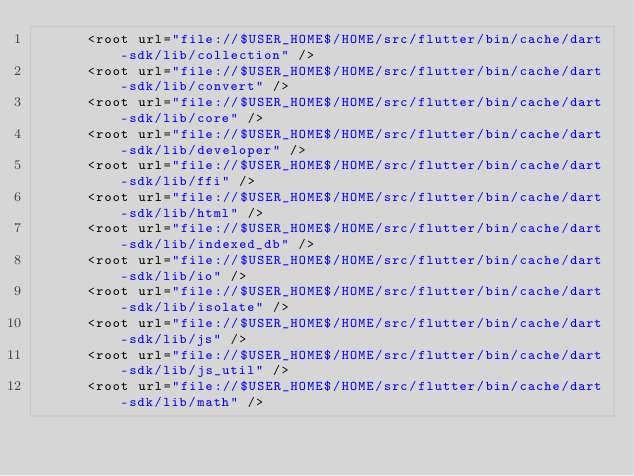Convert code to text. <code><loc_0><loc_0><loc_500><loc_500><_XML_>      <root url="file://$USER_HOME$/HOME/src/flutter/bin/cache/dart-sdk/lib/collection" />
      <root url="file://$USER_HOME$/HOME/src/flutter/bin/cache/dart-sdk/lib/convert" />
      <root url="file://$USER_HOME$/HOME/src/flutter/bin/cache/dart-sdk/lib/core" />
      <root url="file://$USER_HOME$/HOME/src/flutter/bin/cache/dart-sdk/lib/developer" />
      <root url="file://$USER_HOME$/HOME/src/flutter/bin/cache/dart-sdk/lib/ffi" />
      <root url="file://$USER_HOME$/HOME/src/flutter/bin/cache/dart-sdk/lib/html" />
      <root url="file://$USER_HOME$/HOME/src/flutter/bin/cache/dart-sdk/lib/indexed_db" />
      <root url="file://$USER_HOME$/HOME/src/flutter/bin/cache/dart-sdk/lib/io" />
      <root url="file://$USER_HOME$/HOME/src/flutter/bin/cache/dart-sdk/lib/isolate" />
      <root url="file://$USER_HOME$/HOME/src/flutter/bin/cache/dart-sdk/lib/js" />
      <root url="file://$USER_HOME$/HOME/src/flutter/bin/cache/dart-sdk/lib/js_util" />
      <root url="file://$USER_HOME$/HOME/src/flutter/bin/cache/dart-sdk/lib/math" /></code> 